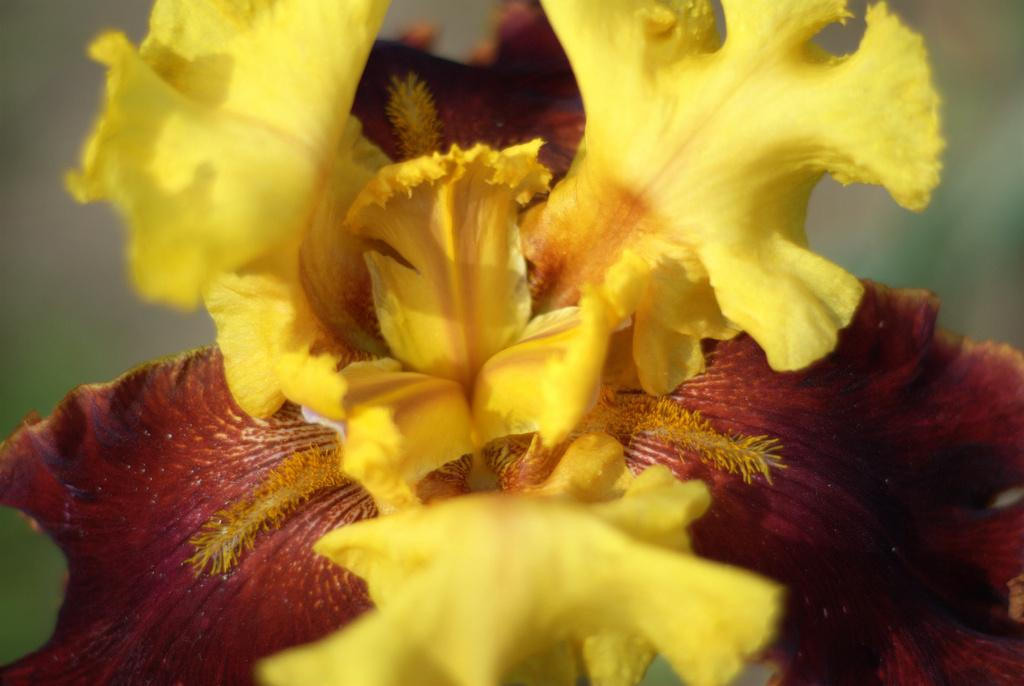What colors of flowers can be seen in the image? There is a yellow flower and a red flower in the image. What type of battle is taking place between the flowers in the image? There is no battle taking place between the flowers in the image, as they are simply flowers and not engaged in any conflict. 